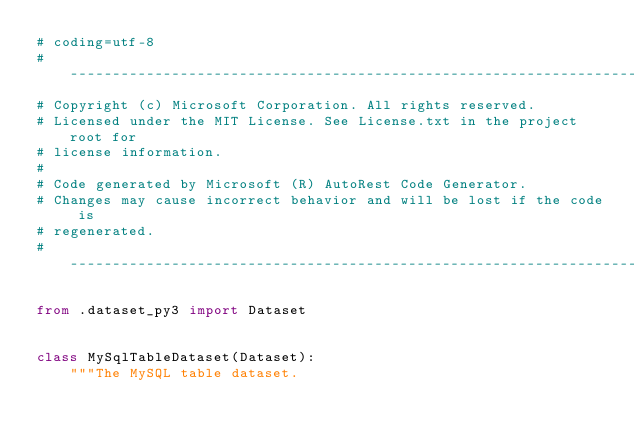Convert code to text. <code><loc_0><loc_0><loc_500><loc_500><_Python_># coding=utf-8
# --------------------------------------------------------------------------
# Copyright (c) Microsoft Corporation. All rights reserved.
# Licensed under the MIT License. See License.txt in the project root for
# license information.
#
# Code generated by Microsoft (R) AutoRest Code Generator.
# Changes may cause incorrect behavior and will be lost if the code is
# regenerated.
# --------------------------------------------------------------------------

from .dataset_py3 import Dataset


class MySqlTableDataset(Dataset):
    """The MySQL table dataset.
</code> 